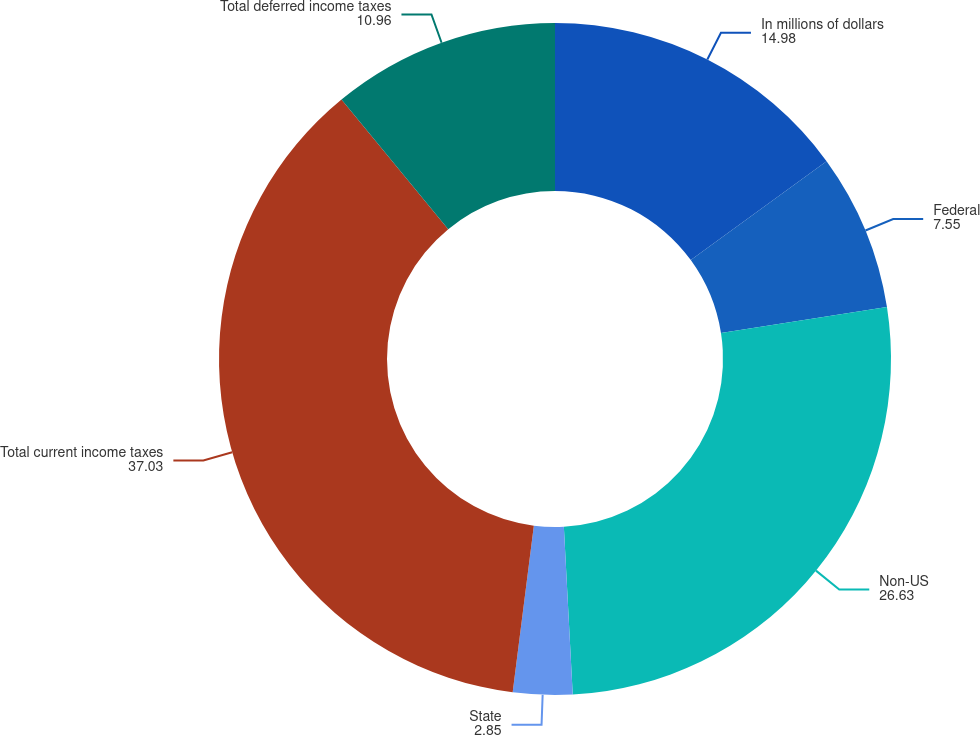<chart> <loc_0><loc_0><loc_500><loc_500><pie_chart><fcel>In millions of dollars<fcel>Federal<fcel>Non-US<fcel>State<fcel>Total current income taxes<fcel>Total deferred income taxes<nl><fcel>14.98%<fcel>7.55%<fcel>26.63%<fcel>2.85%<fcel>37.03%<fcel>10.96%<nl></chart> 